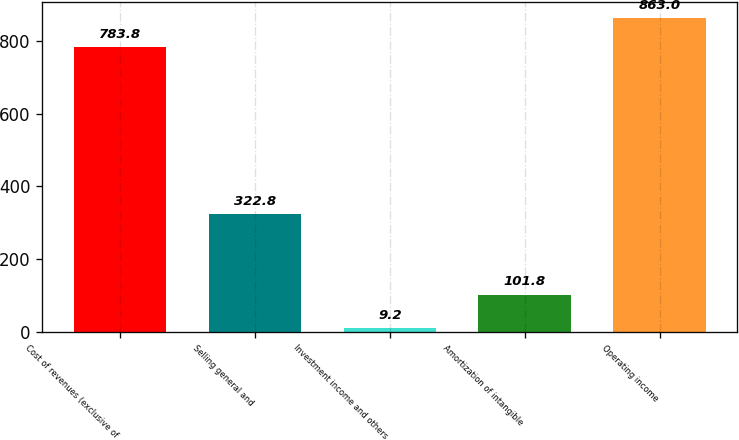Convert chart to OTSL. <chart><loc_0><loc_0><loc_500><loc_500><bar_chart><fcel>Cost of revenues (exclusive of<fcel>Selling general and<fcel>Investment income and others<fcel>Amortization of intangible<fcel>Operating income<nl><fcel>783.8<fcel>322.8<fcel>9.2<fcel>101.8<fcel>863<nl></chart> 